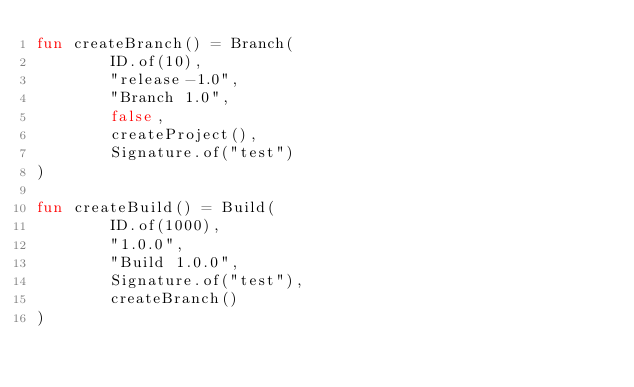<code> <loc_0><loc_0><loc_500><loc_500><_Kotlin_>fun createBranch() = Branch(
        ID.of(10),
        "release-1.0",
        "Branch 1.0",
        false,
        createProject(),
        Signature.of("test")
)

fun createBuild() = Build(
        ID.of(1000),
        "1.0.0",
        "Build 1.0.0",
        Signature.of("test"),
        createBranch()
)
</code> 